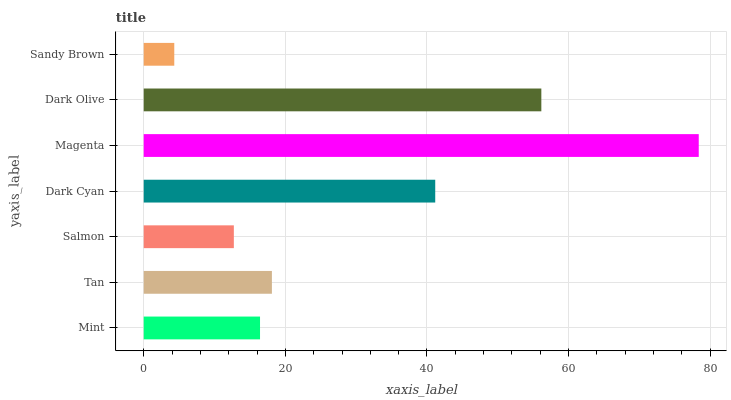Is Sandy Brown the minimum?
Answer yes or no. Yes. Is Magenta the maximum?
Answer yes or no. Yes. Is Tan the minimum?
Answer yes or no. No. Is Tan the maximum?
Answer yes or no. No. Is Tan greater than Mint?
Answer yes or no. Yes. Is Mint less than Tan?
Answer yes or no. Yes. Is Mint greater than Tan?
Answer yes or no. No. Is Tan less than Mint?
Answer yes or no. No. Is Tan the high median?
Answer yes or no. Yes. Is Tan the low median?
Answer yes or no. Yes. Is Dark Cyan the high median?
Answer yes or no. No. Is Dark Olive the low median?
Answer yes or no. No. 